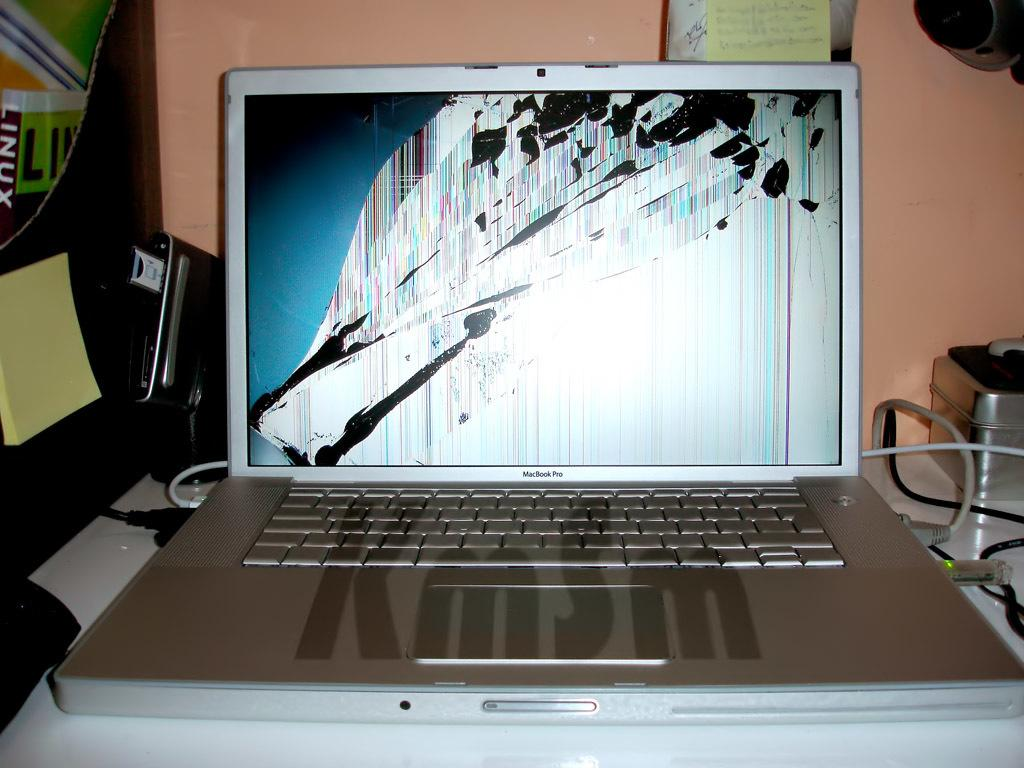<image>
Relay a brief, clear account of the picture shown. A silver laptop that says Mac Book Pro has a broken screen. 